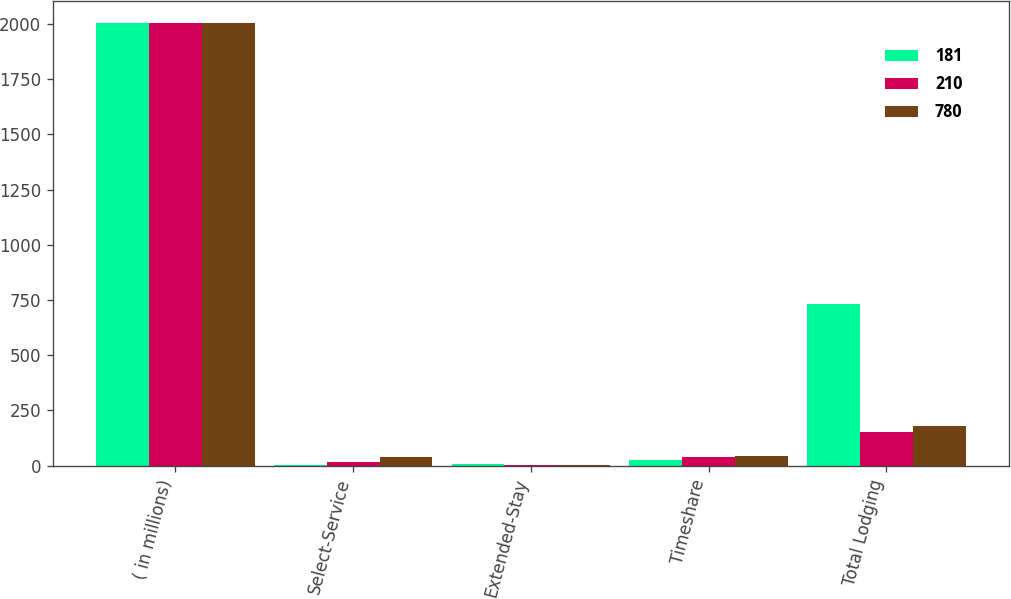Convert chart to OTSL. <chart><loc_0><loc_0><loc_500><loc_500><stacked_bar_chart><ecel><fcel>( in millions)<fcel>Select-Service<fcel>Extended-Stay<fcel>Timeshare<fcel>Total Lodging<nl><fcel>181<fcel>2005<fcel>4<fcel>6<fcel>27<fcel>734<nl><fcel>210<fcel>2004<fcel>16<fcel>1<fcel>38<fcel>150<nl><fcel>780<fcel>2003<fcel>38<fcel>3<fcel>45<fcel>179<nl></chart> 